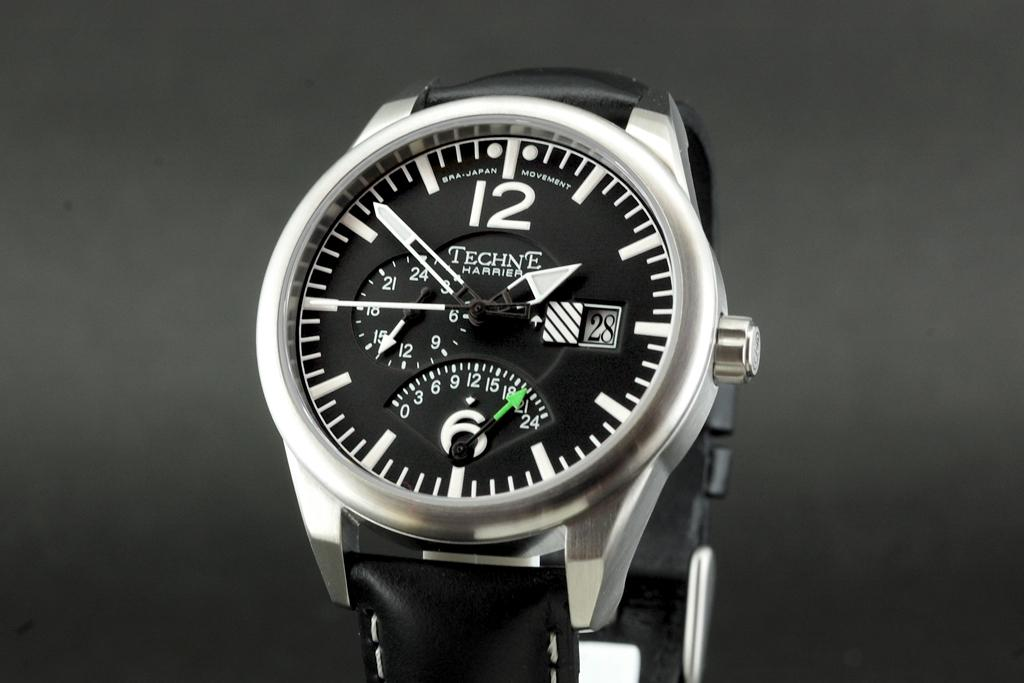Provide a one-sentence caption for the provided image. Techne is the company who makes the watch. 